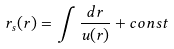<formula> <loc_0><loc_0><loc_500><loc_500>r _ { s } ( r ) = \int \frac { d r } { u ( r ) } + c o n s t</formula> 